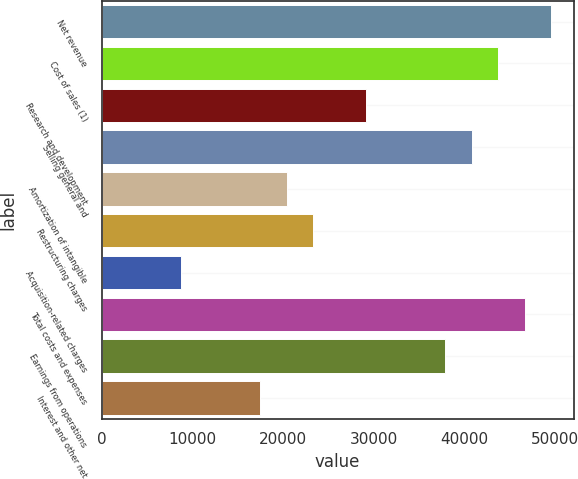Convert chart. <chart><loc_0><loc_0><loc_500><loc_500><bar_chart><fcel>Net revenue<fcel>Cost of sales (1)<fcel>Research and development<fcel>Selling general and<fcel>Amortization of intangible<fcel>Restructuring charges<fcel>Acquisition-related charges<fcel>Total costs and expenses<fcel>Earnings from operations<fcel>Interest and other net<nl><fcel>49522.6<fcel>43696.4<fcel>29131<fcel>40783.3<fcel>20391.8<fcel>23304.8<fcel>8739.4<fcel>46609.5<fcel>37870.2<fcel>17478.7<nl></chart> 